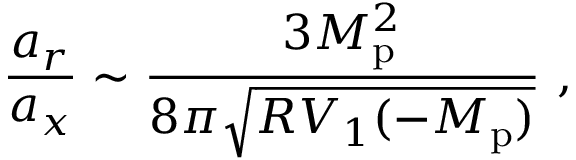<formula> <loc_0><loc_0><loc_500><loc_500>\frac { a _ { r } } { a _ { x } } \sim \frac { 3 M _ { p } ^ { 2 } } { 8 \pi \sqrt { R V _ { 1 } ( - M _ { p } ) } } \ ,</formula> 